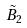Convert formula to latex. <formula><loc_0><loc_0><loc_500><loc_500>\tilde { B } _ { 2 }</formula> 